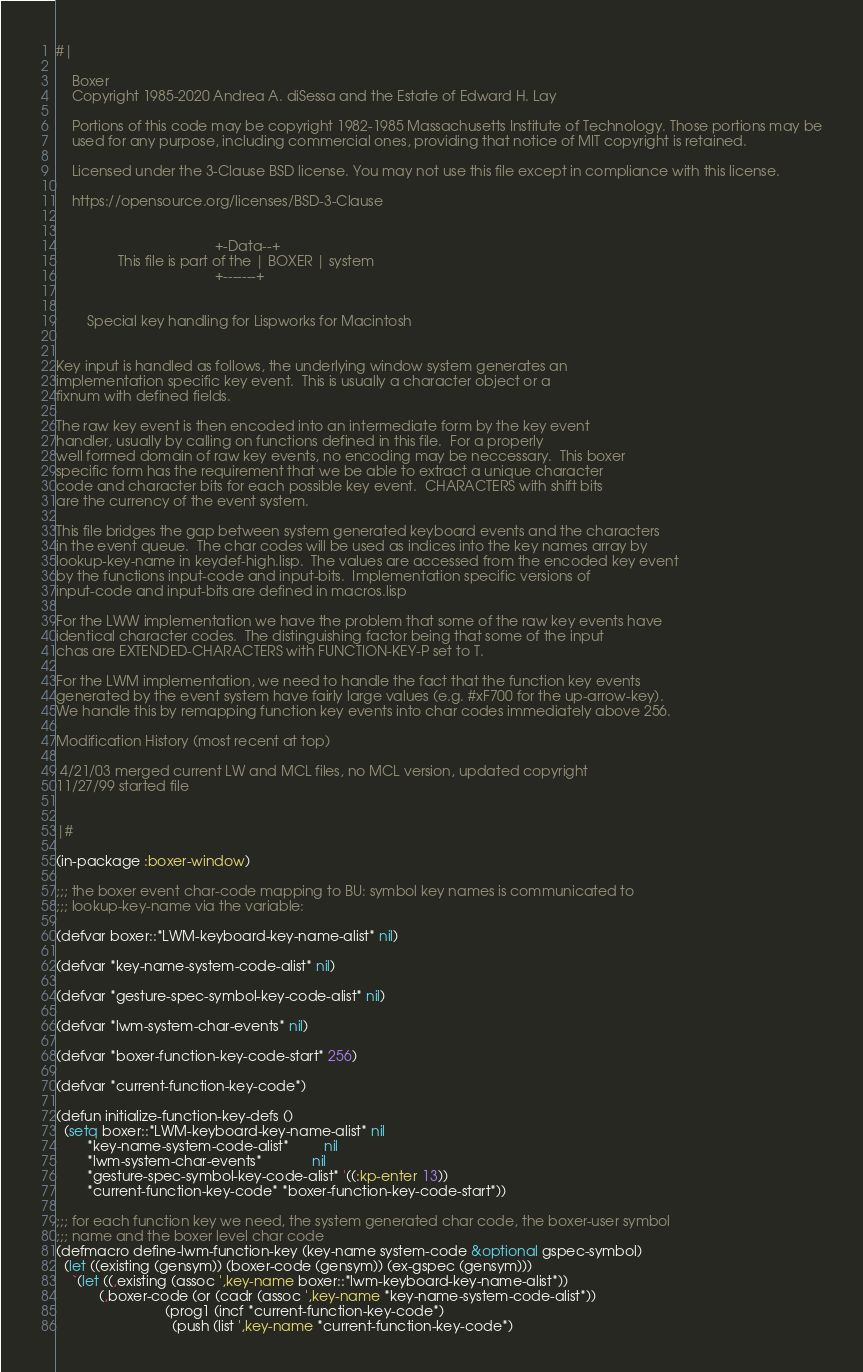Convert code to text. <code><loc_0><loc_0><loc_500><loc_500><_Lisp_>#|

    Boxer
    Copyright 1985-2020 Andrea A. diSessa and the Estate of Edward H. Lay

    Portions of this code may be copyright 1982-1985 Massachusetts Institute of Technology. Those portions may be
    used for any purpose, including commercial ones, providing that notice of MIT copyright is retained.

    Licensed under the 3-Clause BSD license. You may not use this file except in compliance with this license.

    https://opensource.org/licenses/BSD-3-Clause


                                         +-Data--+
                This file is part of the | BOXER | system
                                         +-------+


        Special key handling for Lispworks for Macintosh


Key input is handled as follows, the underlying window system generates an
implementation specific key event.  This is usually a character object or a
fixnum with defined fields.

The raw key event is then encoded into an intermediate form by the key event
handler, usually by calling on functions defined in this file.  For a properly
well formed domain of raw key events, no encoding may be neccessary.  This boxer
specific form has the requirement that we be able to extract a unique character
code and character bits for each possible key event.  CHARACTERS with shift bits
are the currency of the event system.

This file bridges the gap between system generated keyboard events and the characters
in the event queue.  The char codes will be used as indices into the key names array by
lookup-key-name in keydef-high.lisp.  The values are accessed from the encoded key event
by the functions input-code and input-bits.  Implementation specific versions of
input-code and input-bits are defined in macros.lisp

For the LWW implementation we have the problem that some of the raw key events have
identical character codes.  The distinguishing factor being that some of the input
chas are EXTENDED-CHARACTERS with FUNCTION-KEY-P set to T.

For the LWM implementation, we need to handle the fact that the function key events
generated by the event system have fairly large values (e.g. #xF700 for the up-arrow-key).
We handle this by remapping function key events into char codes immediately above 256.

Modification History (most recent at top)

 4/21/03 merged current LW and MCL files, no MCL version, updated copyright
11/27/99 started file


|#

(in-package :boxer-window)

;;; the boxer event char-code mapping to BU: symbol key names is communicated to
;;; lookup-key-name via the variable:

(defvar boxer::*LWM-keyboard-key-name-alist* nil)

(defvar *key-name-system-code-alist* nil)

(defvar *gesture-spec-symbol-key-code-alist* nil)

(defvar *lwm-system-char-events* nil)

(defvar *boxer-function-key-code-start* 256)

(defvar *current-function-key-code*)

(defun initialize-function-key-defs ()
  (setq boxer::*LWM-keyboard-key-name-alist* nil
        *key-name-system-code-alist*         nil
        *lwm-system-char-events*             nil
        *gesture-spec-symbol-key-code-alist* '((:kp-enter 13))
        *current-function-key-code* *boxer-function-key-code-start*))

;;; for each function key we need, the system generated char code, the boxer-user symbol
;;; name and the boxer level char code
(defmacro define-lwm-function-key (key-name system-code &optional gspec-symbol)
  (let ((existing (gensym)) (boxer-code (gensym)) (ex-gspec (gensym)))
    `(let ((,existing (assoc ',key-name boxer::*lwm-keyboard-key-name-alist*))
           (,boxer-code (or (cadr (assoc ',key-name *key-name-system-code-alist*))
                            (prog1 (incf *current-function-key-code*)
                              (push (list ',key-name *current-function-key-code*)</code> 